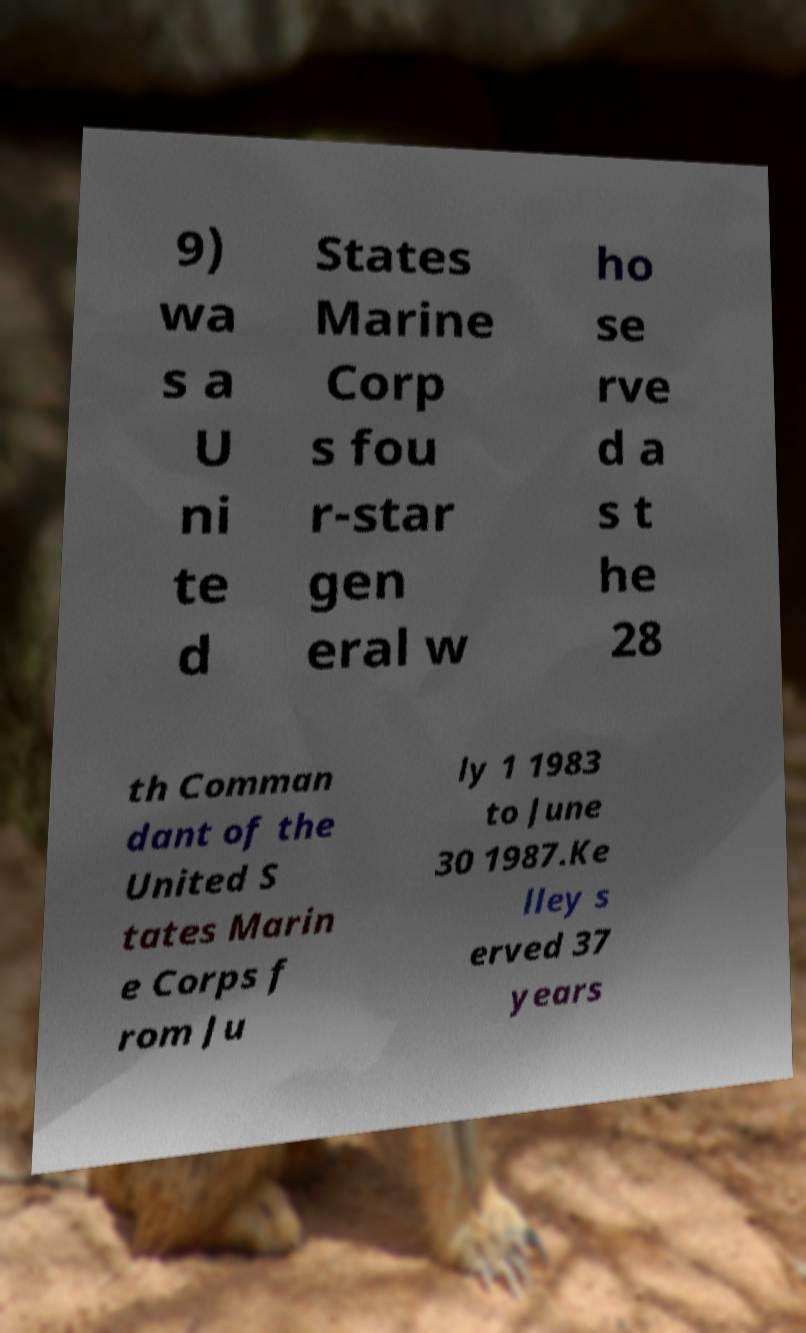For documentation purposes, I need the text within this image transcribed. Could you provide that? 9) wa s a U ni te d States Marine Corp s fou r-star gen eral w ho se rve d a s t he 28 th Comman dant of the United S tates Marin e Corps f rom Ju ly 1 1983 to June 30 1987.Ke lley s erved 37 years 